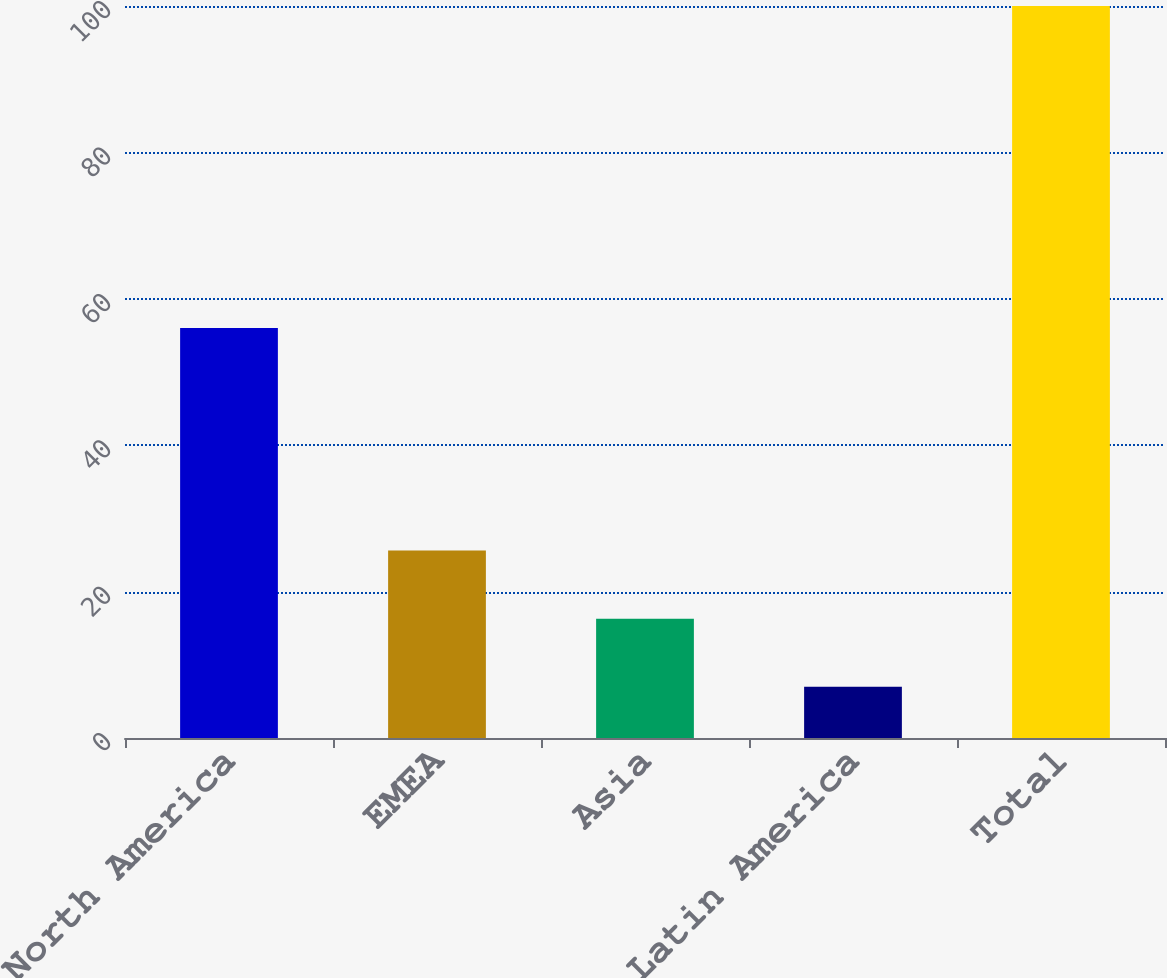Convert chart. <chart><loc_0><loc_0><loc_500><loc_500><bar_chart><fcel>North America<fcel>EMEA<fcel>Asia<fcel>Latin America<fcel>Total<nl><fcel>56<fcel>25.6<fcel>16.3<fcel>7<fcel>100<nl></chart> 